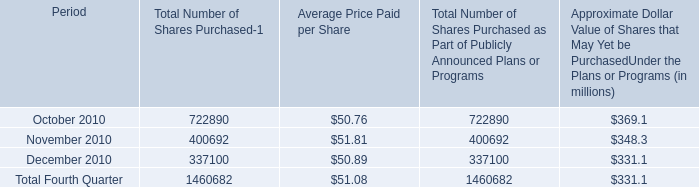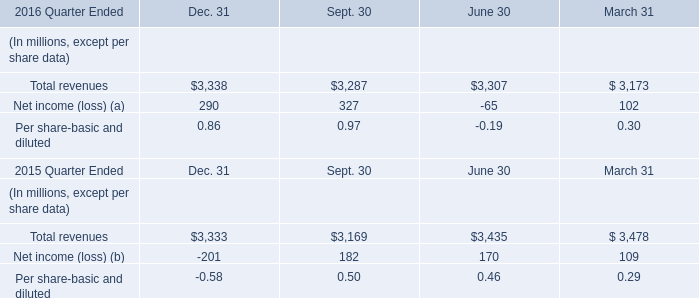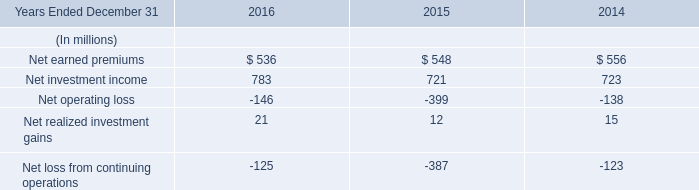What's the total value of all elements for Net income (loss) (a) that are smaller than 200 in 2016? (in million) 
Computations: (-65 + 102)
Answer: 37.0. 